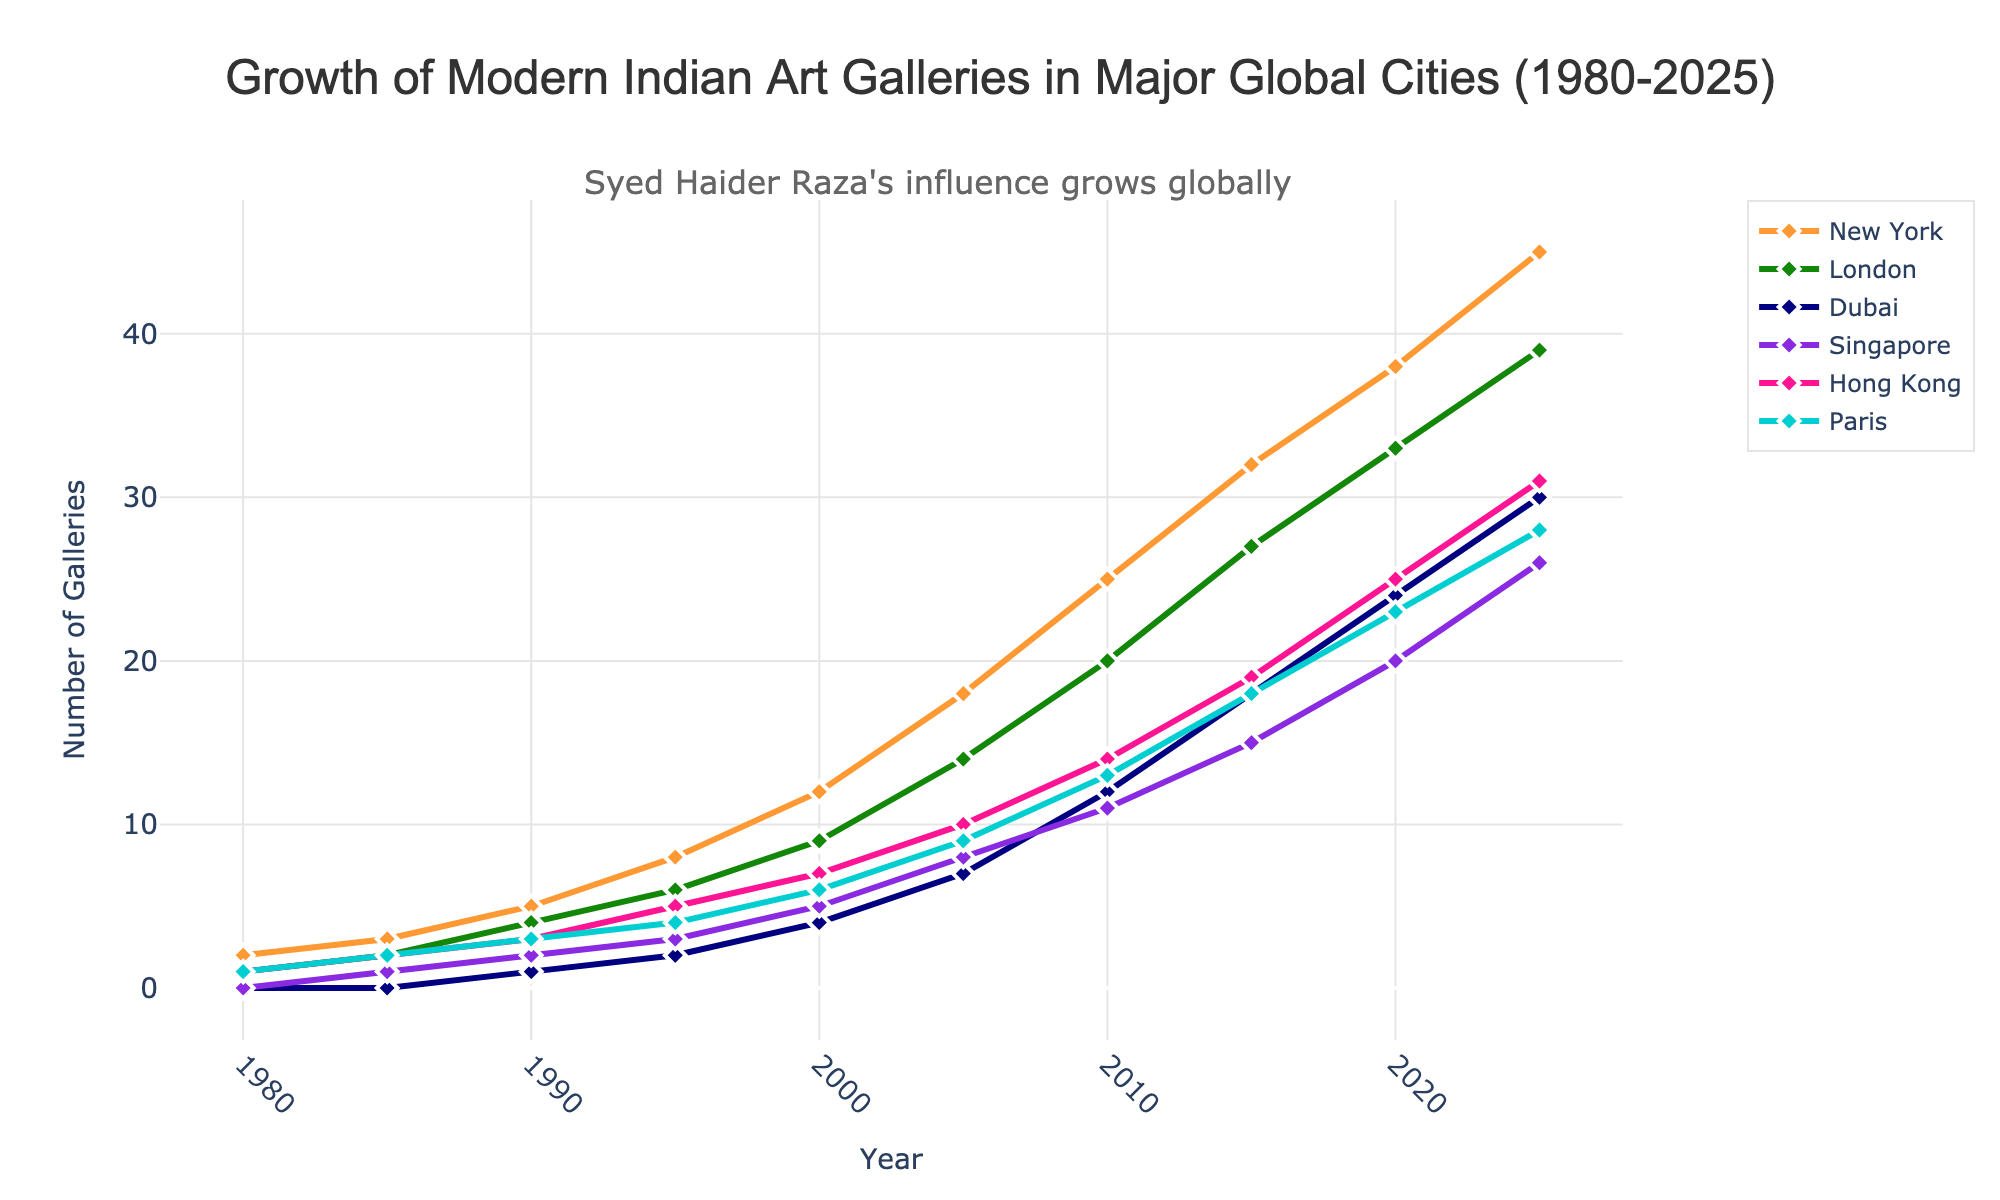What city showed the greatest increase in the number of modern Indian art galleries from 1980 to 2025? Consider the values for each city in 1980 and 2025. New York increased from 2 to 45, London from 1 to 39, Dubai from 0 to 30, Singapore from 0 to 26, Hong Kong from 1 to 31, and Paris from 1 to 28. Thus, New York showed the greatest increase.
Answer: New York By how many galleries did the number of modern Indian art galleries in Dubai increase between 1995 and 2010? In 1995, Dubai had 2 galleries, and this number increased to 12 by 2010. The increase is 12 - 2 = 10 galleries.
Answer: 10 How does the number of galleries in Paris in 2020 compare to that in Singapore in the same year? In 2020, Paris had 23 galleries, and Singapore had 20 galleries. Thus, Paris had 3 more galleries than Singapore.
Answer: Paris had 3 more galleries What is the total number of modern Indian art galleries in Hong Kong, Dubai, and Singapore combined in 2015? In 2015, Hong Kong had 19 galleries, Dubai had 18 galleries, and Singapore had 15 galleries. The total is 19 + 18 + 15 = 52 galleries.
Answer: 52 Which city had the smallest number of modern Indian art galleries in 1985? In 1985, both Dubai and Singapore had no modern Indian art galleries, the lowest among the cities listed.
Answer: Dubai and Singapore What is the difference in the number of modern Indian art galleries between New York and London in 2025? In 2025, New York had 45 galleries, and London had 39 galleries. The difference is 45 - 39 = 6 galleries.
Answer: 6 Which city shows the fastest growth rate in the number of modern Indian art galleries between 2000 and 2005? Calculate the growth rate as (number in 2005 - number in 2000) / number in 2000. For New York: (18 - 12) / 12 = 0.5 or 50%. For London: (14 - 9) / 9 = 0.555 or 55.5%. For Dubai: (7 - 4) / 4 = 0.75 or 75%. For Singapore: (8 - 5) / 5 = 0.6 or 60%. For Hong Kong: (10 - 7) / 7 = 0.428 or 42.8%. For Paris: (9 - 6) / 6 = 0.5 or 50%. Dubai shows the fastest growth rate.
Answer: Dubai How many modern Indian art galleries did London have in 1990? Check the figure for London in the year 1990, which shows 4 galleries.
Answer: 4 Which city had the most modern Indian art galleries in 2010 and how many did it have? In 2010, the city with the most galleries is New York with 25 galleries.
Answer: New York, 25 Between which two consecutive years did Singapore see the biggest increase in the number of modern Indian art galleries? Compare the increases between consecutive years for Singapore: 1985-1990: 1, 1990-1995: 1, 1995-2000: 2, 2000-2005: 3, 2005-2010: 3, 2010-2015: 4, 2015-2020: 5, 2020-2025: 6. The biggest increase was from 2020 to 2025.
Answer: 2020 to 2025 